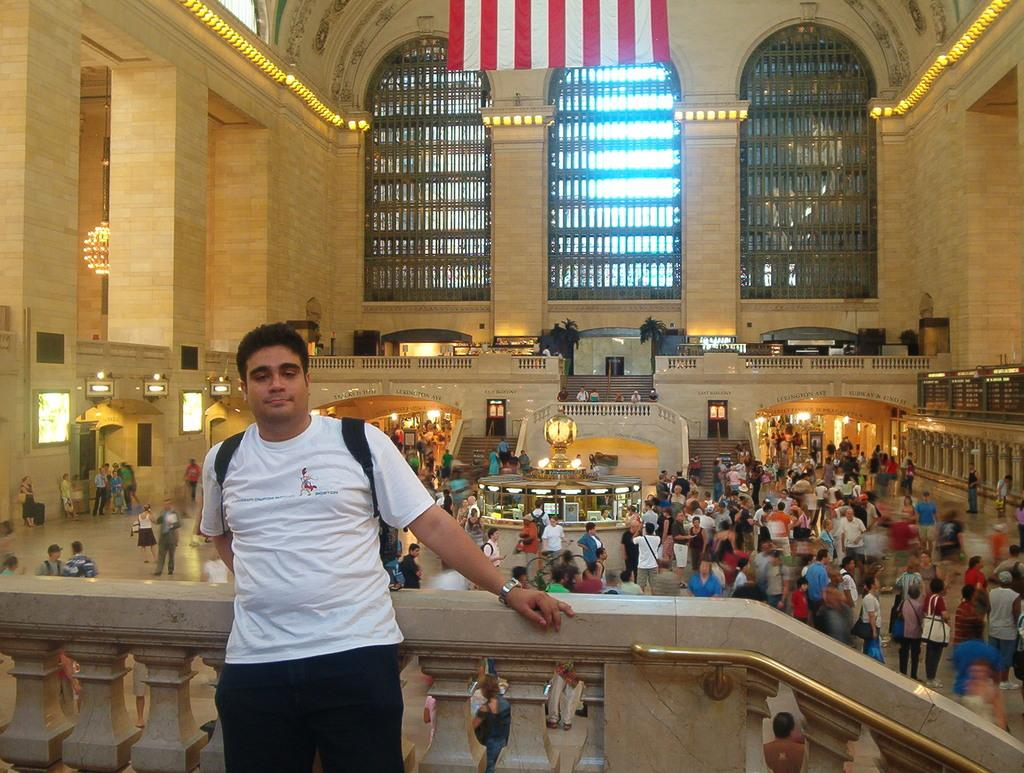What is the man in the image doing? The man is posing to a camera in the image. What can be seen in the background of the image? There is a group of people, lights, screens, doors, a flag, pillars, and a wall visible in the background of the image. What hobbies do the kittens enjoy in the image? There are no kittens present in the image, so it is not possible to determine their hobbies. 